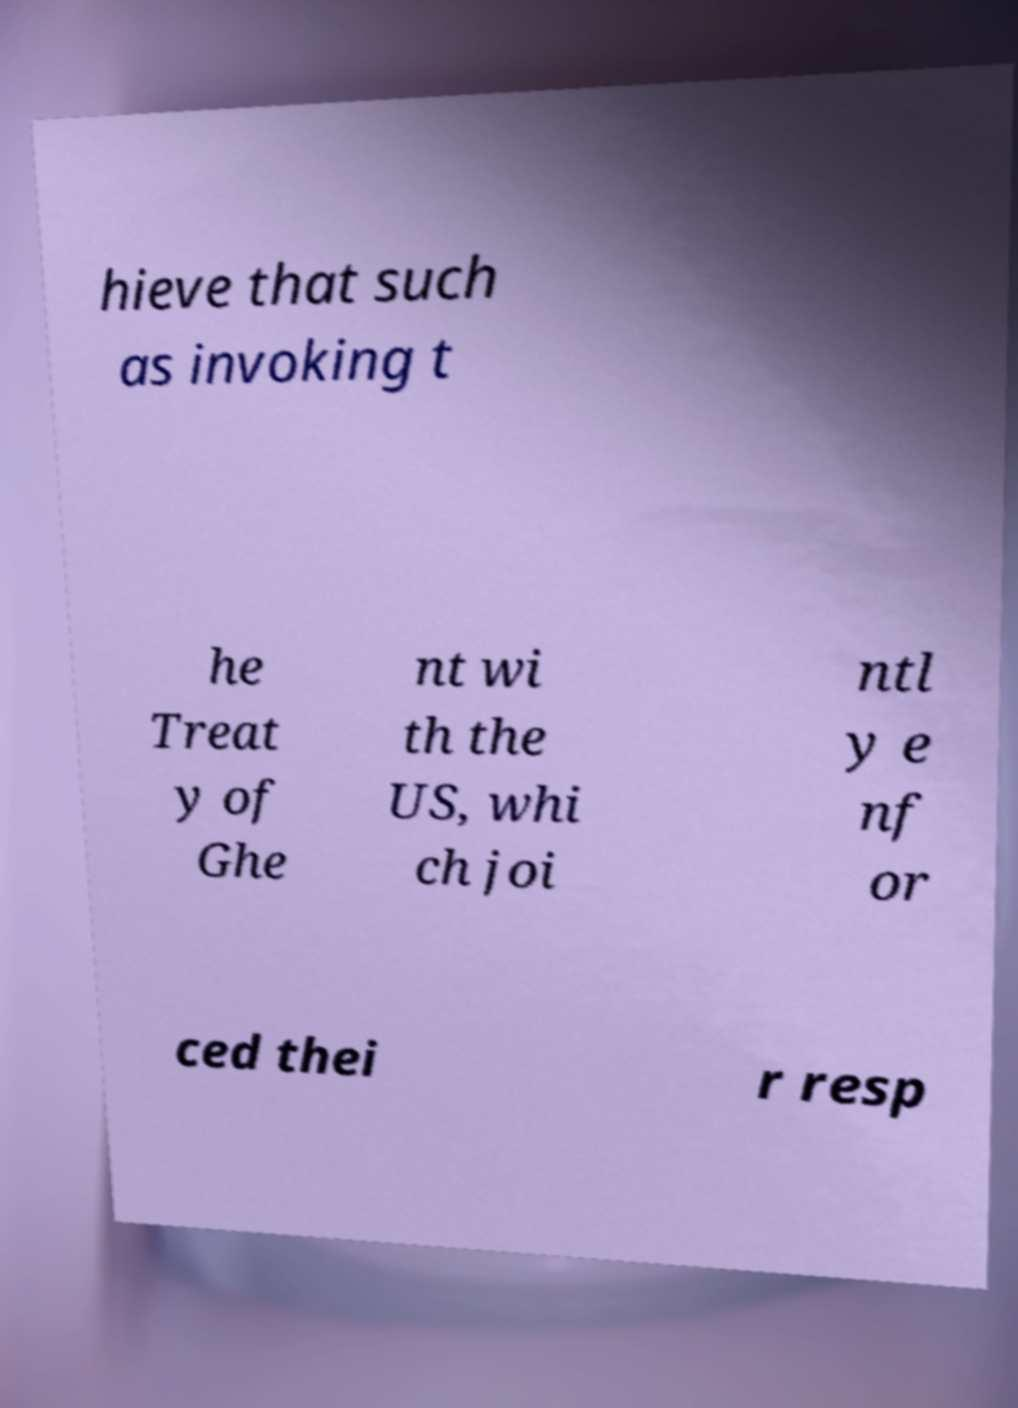There's text embedded in this image that I need extracted. Can you transcribe it verbatim? hieve that such as invoking t he Treat y of Ghe nt wi th the US, whi ch joi ntl y e nf or ced thei r resp 